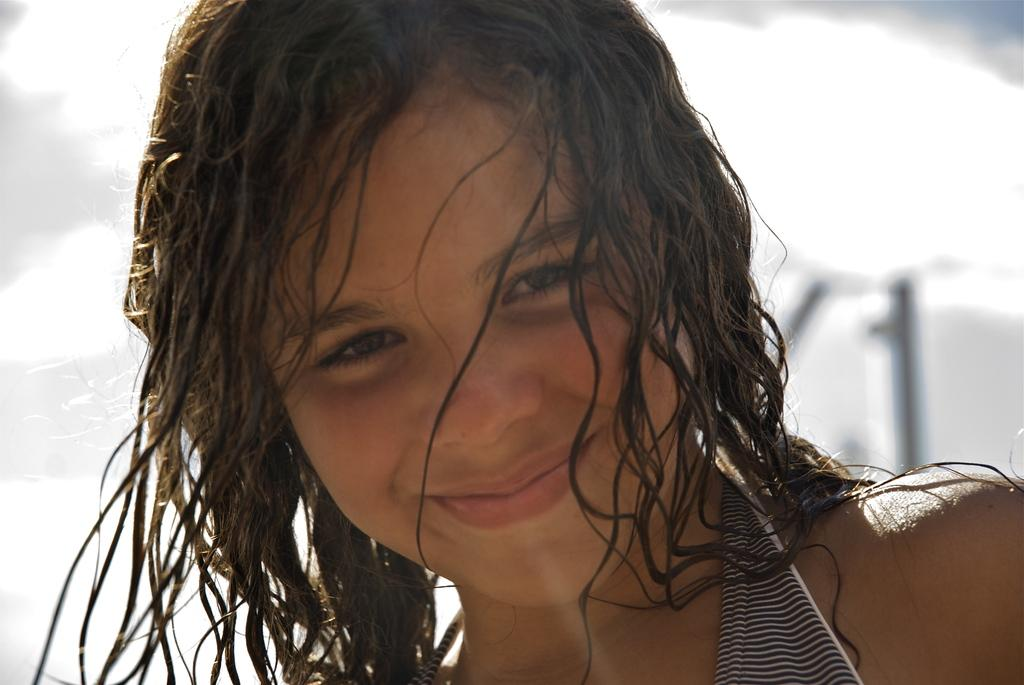What is the main subject of the image? There is a picture of a girl in the image. What is the girl's expression in the image? The girl is smiling in the image. What color is the background of the image? The background of the image is white. Can you tell me how many cellars are visible in the image? There are no cellars present in the image; it features a picture of a girl with a white background. What type of laugh can be heard coming from the girl in the image? There is no sound in the image, so it is not possible to determine what type of laugh might be heard. 